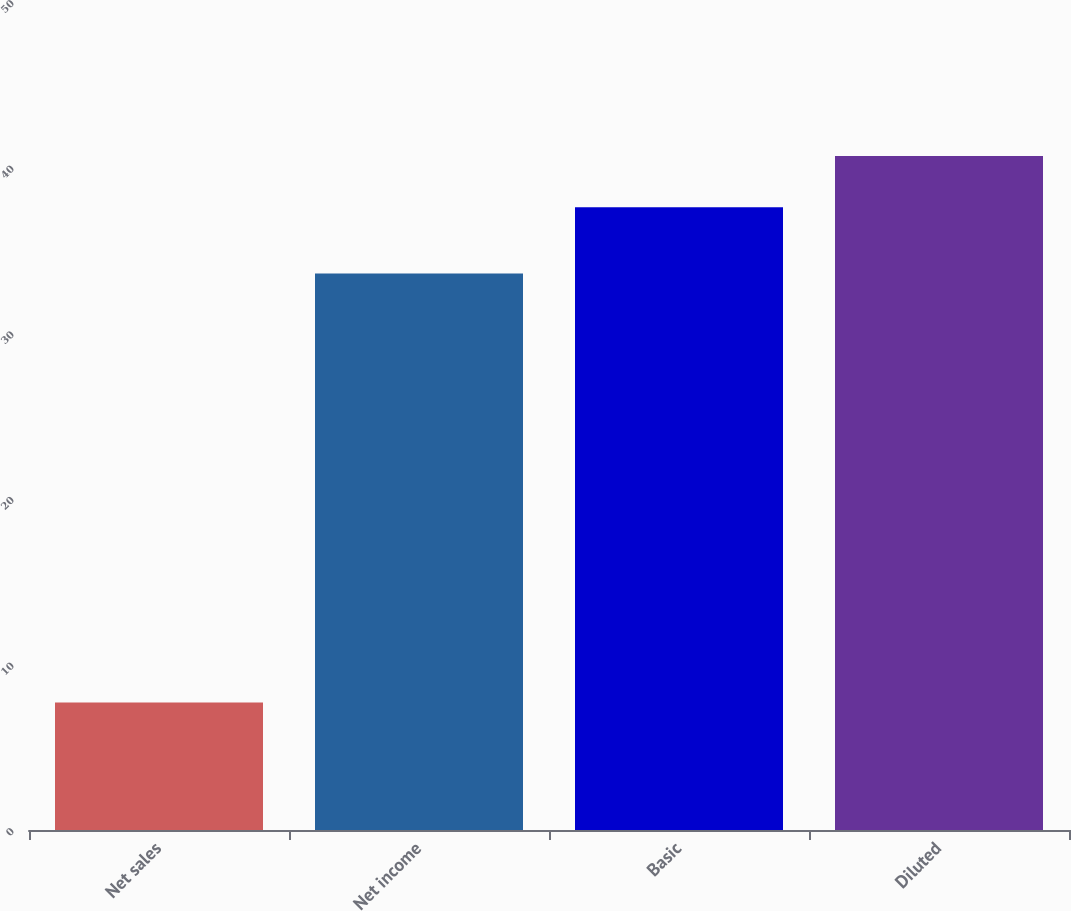Convert chart to OTSL. <chart><loc_0><loc_0><loc_500><loc_500><bar_chart><fcel>Net sales<fcel>Net income<fcel>Basic<fcel>Diluted<nl><fcel>7.7<fcel>33.6<fcel>37.6<fcel>40.7<nl></chart> 